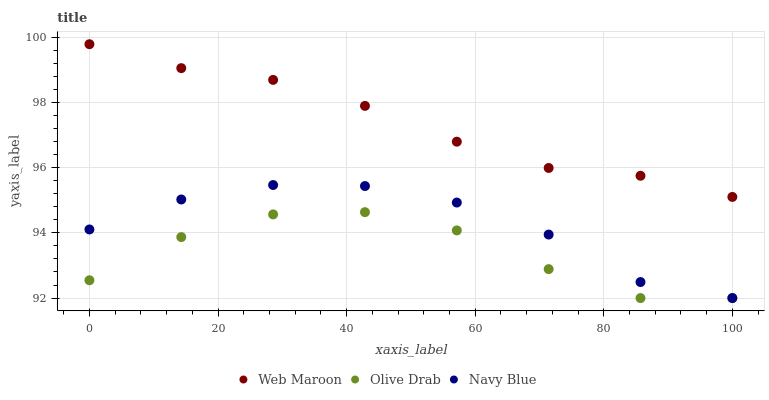Does Olive Drab have the minimum area under the curve?
Answer yes or no. Yes. Does Web Maroon have the maximum area under the curve?
Answer yes or no. Yes. Does Web Maroon have the minimum area under the curve?
Answer yes or no. No. Does Olive Drab have the maximum area under the curve?
Answer yes or no. No. Is Web Maroon the smoothest?
Answer yes or no. Yes. Is Olive Drab the roughest?
Answer yes or no. Yes. Is Olive Drab the smoothest?
Answer yes or no. No. Is Web Maroon the roughest?
Answer yes or no. No. Does Navy Blue have the lowest value?
Answer yes or no. Yes. Does Web Maroon have the lowest value?
Answer yes or no. No. Does Web Maroon have the highest value?
Answer yes or no. Yes. Does Olive Drab have the highest value?
Answer yes or no. No. Is Navy Blue less than Web Maroon?
Answer yes or no. Yes. Is Web Maroon greater than Navy Blue?
Answer yes or no. Yes. Does Navy Blue intersect Olive Drab?
Answer yes or no. Yes. Is Navy Blue less than Olive Drab?
Answer yes or no. No. Is Navy Blue greater than Olive Drab?
Answer yes or no. No. Does Navy Blue intersect Web Maroon?
Answer yes or no. No. 